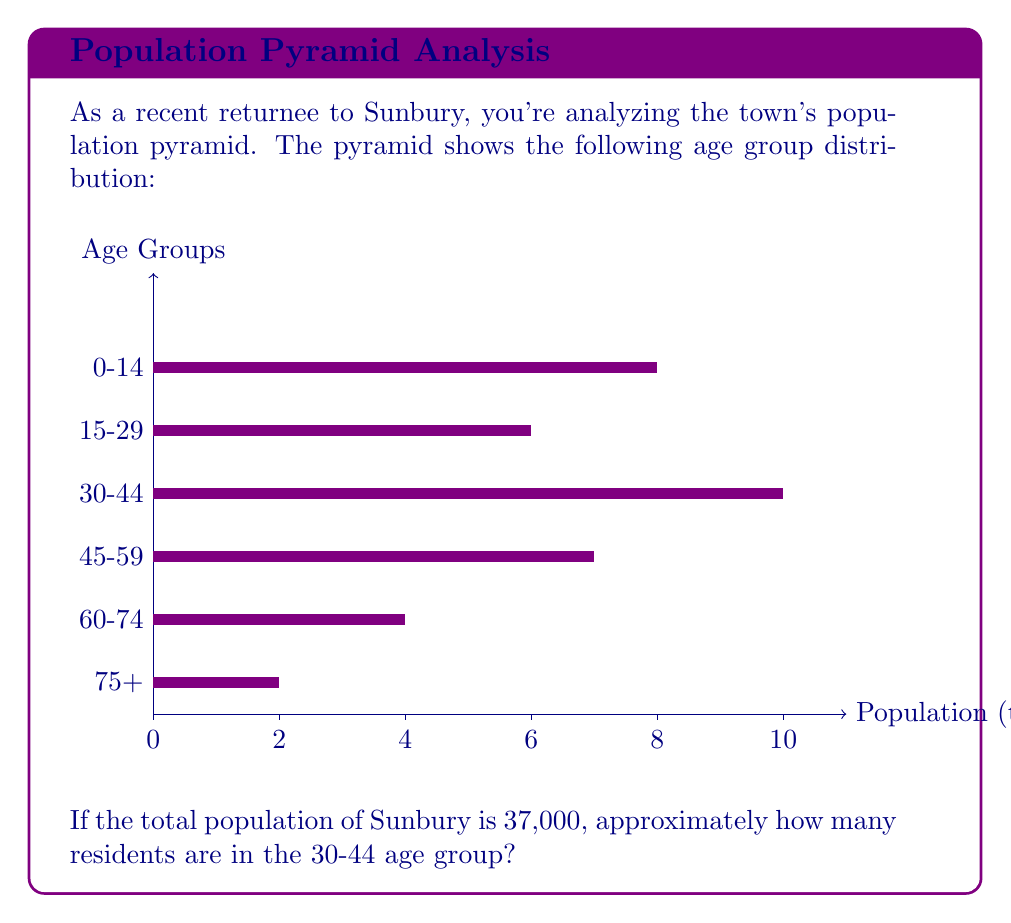Show me your answer to this math problem. To solve this problem, we'll follow these steps:

1) First, we need to calculate the total units represented in the population pyramid:
   $8 + 6 + 10 + 7 + 4 + 2 = 37$ units

2) We know that these 37 units represent the total population of 37,000.
   So, 1 unit = 37,000 ÷ 37 = 1,000 people

3) The 30-44 age group is represented by 10 units in the pyramid.

4) Therefore, the number of people in the 30-44 age group is:
   $10 \times 1,000 = 10,000$ people

Thus, approximately 10,000 residents of Sunbury are in the 30-44 age group.
Answer: 10,000 